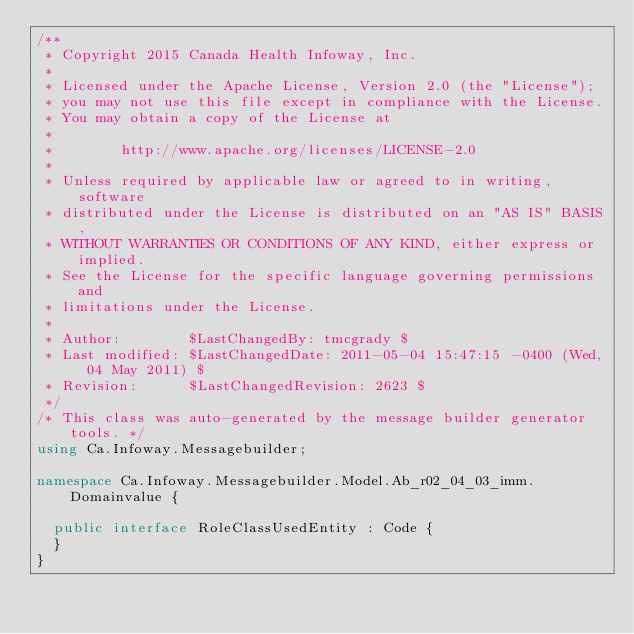<code> <loc_0><loc_0><loc_500><loc_500><_C#_>/**
 * Copyright 2015 Canada Health Infoway, Inc.
 *
 * Licensed under the Apache License, Version 2.0 (the "License");
 * you may not use this file except in compliance with the License.
 * You may obtain a copy of the License at
 *
 *        http://www.apache.org/licenses/LICENSE-2.0
 *
 * Unless required by applicable law or agreed to in writing, software
 * distributed under the License is distributed on an "AS IS" BASIS,
 * WITHOUT WARRANTIES OR CONDITIONS OF ANY KIND, either express or implied.
 * See the License for the specific language governing permissions and
 * limitations under the License.
 *
 * Author:        $LastChangedBy: tmcgrady $
 * Last modified: $LastChangedDate: 2011-05-04 15:47:15 -0400 (Wed, 04 May 2011) $
 * Revision:      $LastChangedRevision: 2623 $
 */
/* This class was auto-generated by the message builder generator tools. */
using Ca.Infoway.Messagebuilder;

namespace Ca.Infoway.Messagebuilder.Model.Ab_r02_04_03_imm.Domainvalue {

  public interface RoleClassUsedEntity : Code {
  }
}
</code> 